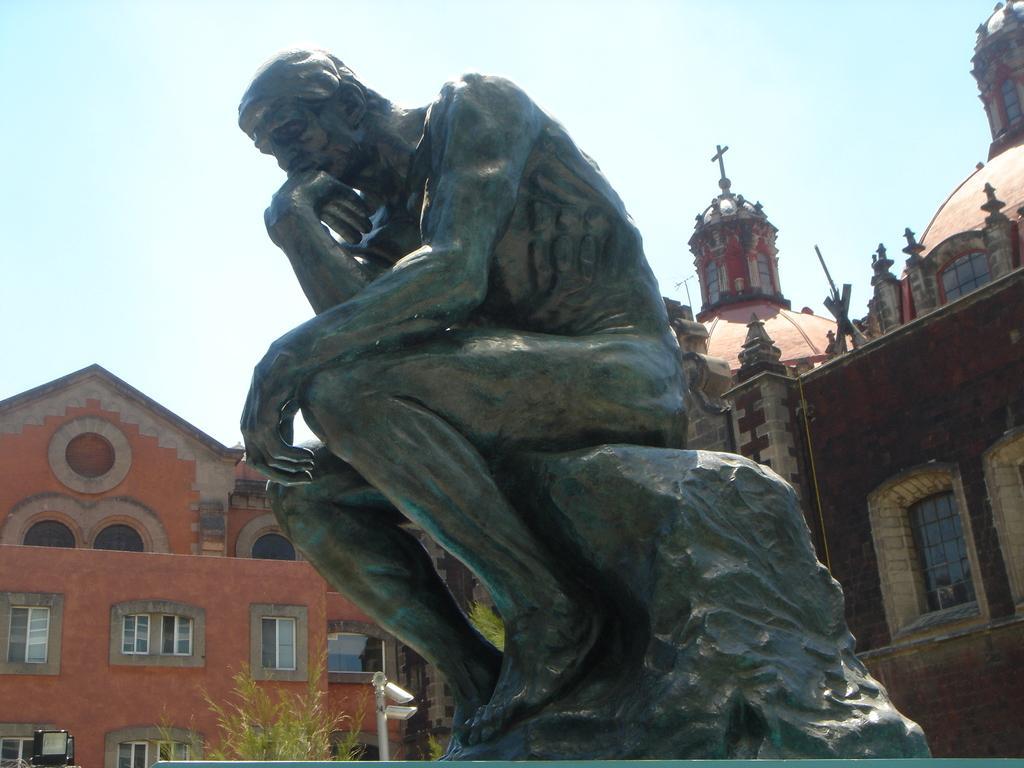Describe this image in one or two sentences. In the image in the center there is a statue, which is in black color. In the background, we can see the sky, clouds, buildings, windows, trees, one pole etc. 